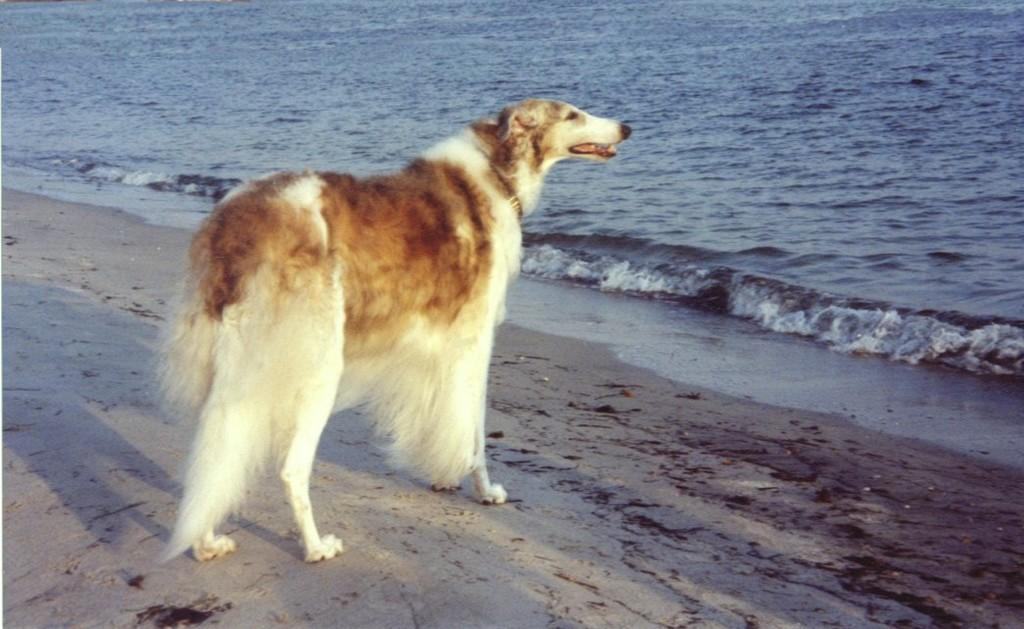What animal is standing in the middle of the image? There is a dog standing in the middle of the image. What natural feature can be seen on the right side of the image? The sea is visible on the right side of the image. What type of journey can be seen the dog taking in the image? There is no journey visible in the image; the dog is standing still in the middle of the image. 